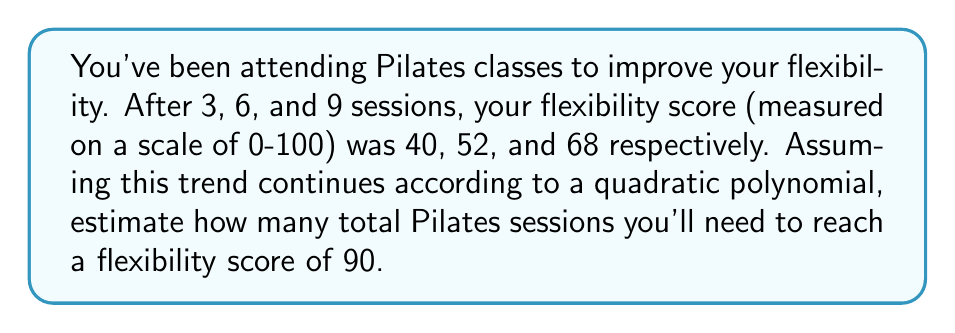Solve this math problem. Let's approach this step-by-step:

1) We'll use a quadratic polynomial of the form $f(x) = ax^2 + bx + c$, where $x$ is the number of sessions and $f(x)$ is the flexibility score.

2) We have three data points:
   $(3, 40)$, $(6, 52)$, and $(9, 68)$

3) Substituting these into our equation:
   $40 = 9a + 3b + c$
   $52 = 36a + 6b + c$
   $68 = 81a + 9b + c$

4) Subtracting the first equation from the second and third:
   $12 = 27a + 3b$
   $28 = 72a + 6b$

5) Simplifying:
   $4 = 9a + b$
   $14 = 36a + 3b$

6) Multiplying the first equation by 3 and subtracting from the second:
   $14 = 36a + 3b$
   $12 = 27a + 3b$
   $2 = 9a$

7) Solving for $a$:
   $a = \frac{2}{9} = 0.2222$

8) Substituting back to find $b$:
   $4 = 9(0.2222) + b$
   $b = 4 - 2 = 2$

9) Using the first original equation to find $c$:
   $40 = 9(0.2222) + 3(2) + c$
   $40 = 2 + 6 + c$
   $c = 32$

10) Our quadratic function is:
    $f(x) = 0.2222x^2 + 2x + 32$

11) To find when this reaches 90, we solve:
    $90 = 0.2222x^2 + 2x + 32$
    $58 = 0.2222x^2 + 2x$
    $0 = 0.2222x^2 + 2x - 58$

12) Using the quadratic formula:
    $x = \frac{-b \pm \sqrt{b^2 - 4ac}}{2a}$
    $x = \frac{-2 \pm \sqrt{4 - 4(0.2222)(-58)}}{2(0.2222)}$
    $x \approx 12.95$ or $x \approx -21.95$

13) Since we can't have negative sessions, we round up to the next whole number of sessions.
Answer: 13 sessions 